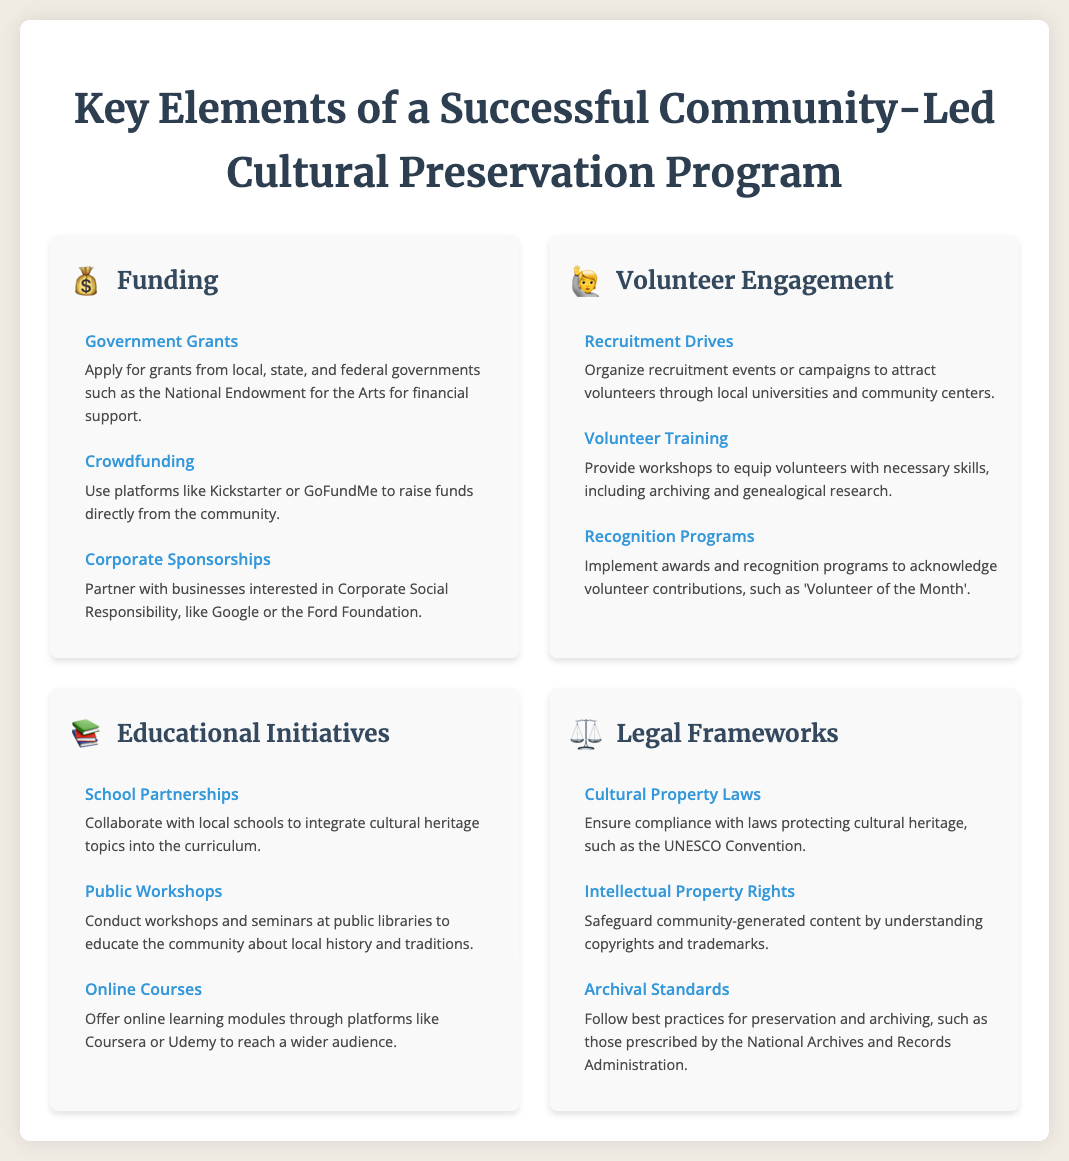What icon represents funding? The icon representing funding is a money bag emoji.
Answer: 💰 What is one source of funding mentioned? One source of funding mentioned is government grants.
Answer: Government Grants How can volunteers be trained? Volunteers can be trained through workshops provided by the program.
Answer: Volunteer Training What is a method for educating the community about cultural heritage? A method for educating the community is conducting public workshops.
Answer: Public Workshops Which legal aspect is mentioned to protect community content? The legal aspect mentioned to protect community content is intellectual property rights.
Answer: Intellectual Property Rights What is the title of the infographic? The title of the infographic is "Key Elements of a Successful Community-Led Cultural Preservation Program."
Answer: Key Elements of a Successful Community-Led Cultural Preservation Program How many key elements are listed in the document? There are four key elements listed in the document.
Answer: Four What type of programs can be used to recognize volunteer contributions? Recognition programs can be implemented to acknowledge volunteer contributions.
Answer: Recognition Programs Name a platform where crowdfunding can occur. One platform where crowdfunding can occur is Kickstarter.
Answer: Kickstarter What kind of laws should cultural preservation programs comply with? Cultural preservation programs should comply with cultural property laws.
Answer: Cultural Property Laws 